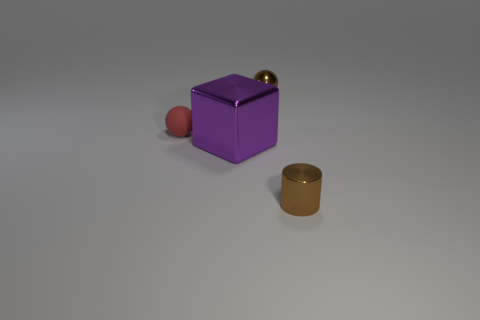Is there anything else that is the same material as the small red thing?
Give a very brief answer. No. What number of big yellow cylinders are there?
Offer a very short reply. 0. How big is the sphere on the right side of the tiny red sphere?
Make the answer very short. Small. Do the red object and the brown metal cylinder have the same size?
Your response must be concise. Yes. What number of things are either large shiny balls or things behind the large shiny cube?
Ensure brevity in your answer.  2. What is the material of the large block?
Offer a terse response. Metal. Is there any other thing of the same color as the big metallic object?
Provide a short and direct response. No. Does the red object have the same shape as the big purple thing?
Offer a very short reply. No. There is a ball behind the tiny ball that is on the left side of the small brown object that is behind the tiny matte ball; what is its size?
Offer a very short reply. Small. What number of other things are made of the same material as the tiny red ball?
Give a very brief answer. 0. 